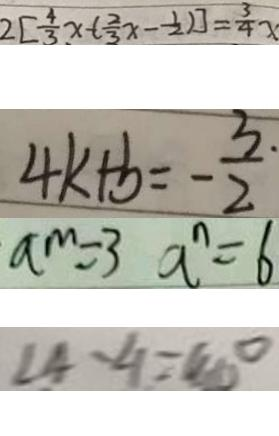<formula> <loc_0><loc_0><loc_500><loc_500>2 [ \frac { 4 } { 3 } x - ( \frac { 2 } { 3 } x - \frac { 1 } { 2 } ) ] = \frac { 3 } { 4 } x 
 4 k + b = - \frac { 3 } { 2 } 
 a ^ { m } = 3 a ^ { n } = 6 
 \angle 4 - \angle 1 = 4 0 ^ { \circ }</formula> 